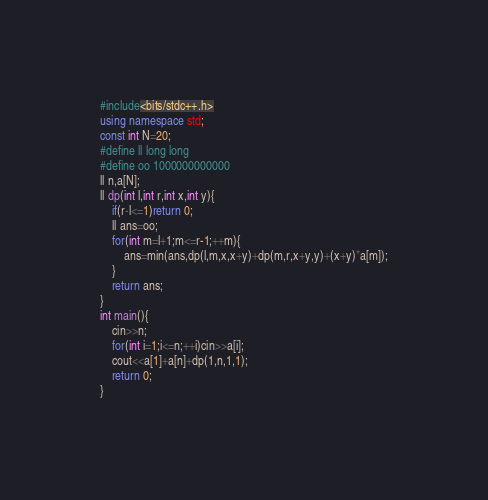<code> <loc_0><loc_0><loc_500><loc_500><_C++_>#include<bits/stdc++.h>
using namespace std;
const int N=20;
#define ll long long
#define oo 1000000000000
ll n,a[N];
ll dp(int l,int r,int x,int y){
	if(r-l<=1)return 0;
	ll ans=oo;
	for(int m=l+1;m<=r-1;++m){
		ans=min(ans,dp(l,m,x,x+y)+dp(m,r,x+y,y)+(x+y)*a[m]);
	}
	return ans;
}
int main(){
	cin>>n;
	for(int i=1;i<=n;++i)cin>>a[i];
	cout<<a[1]+a[n]+dp(1,n,1,1);
	return 0;
} </code> 